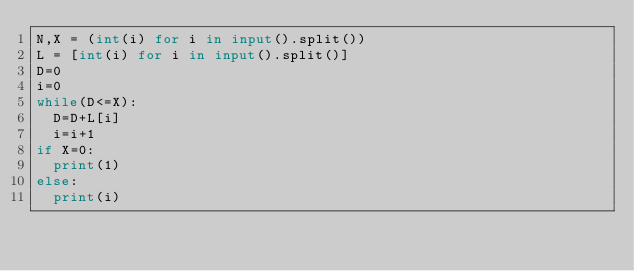<code> <loc_0><loc_0><loc_500><loc_500><_Python_>N,X = (int(i) for i in input().split()) 
L = [int(i) for i in input().split()] 
D=0
i=0
while(D<=X):
  D=D+L[i]
  i=i+1
if X=0:
  print(1)
else:
  print(i)</code> 